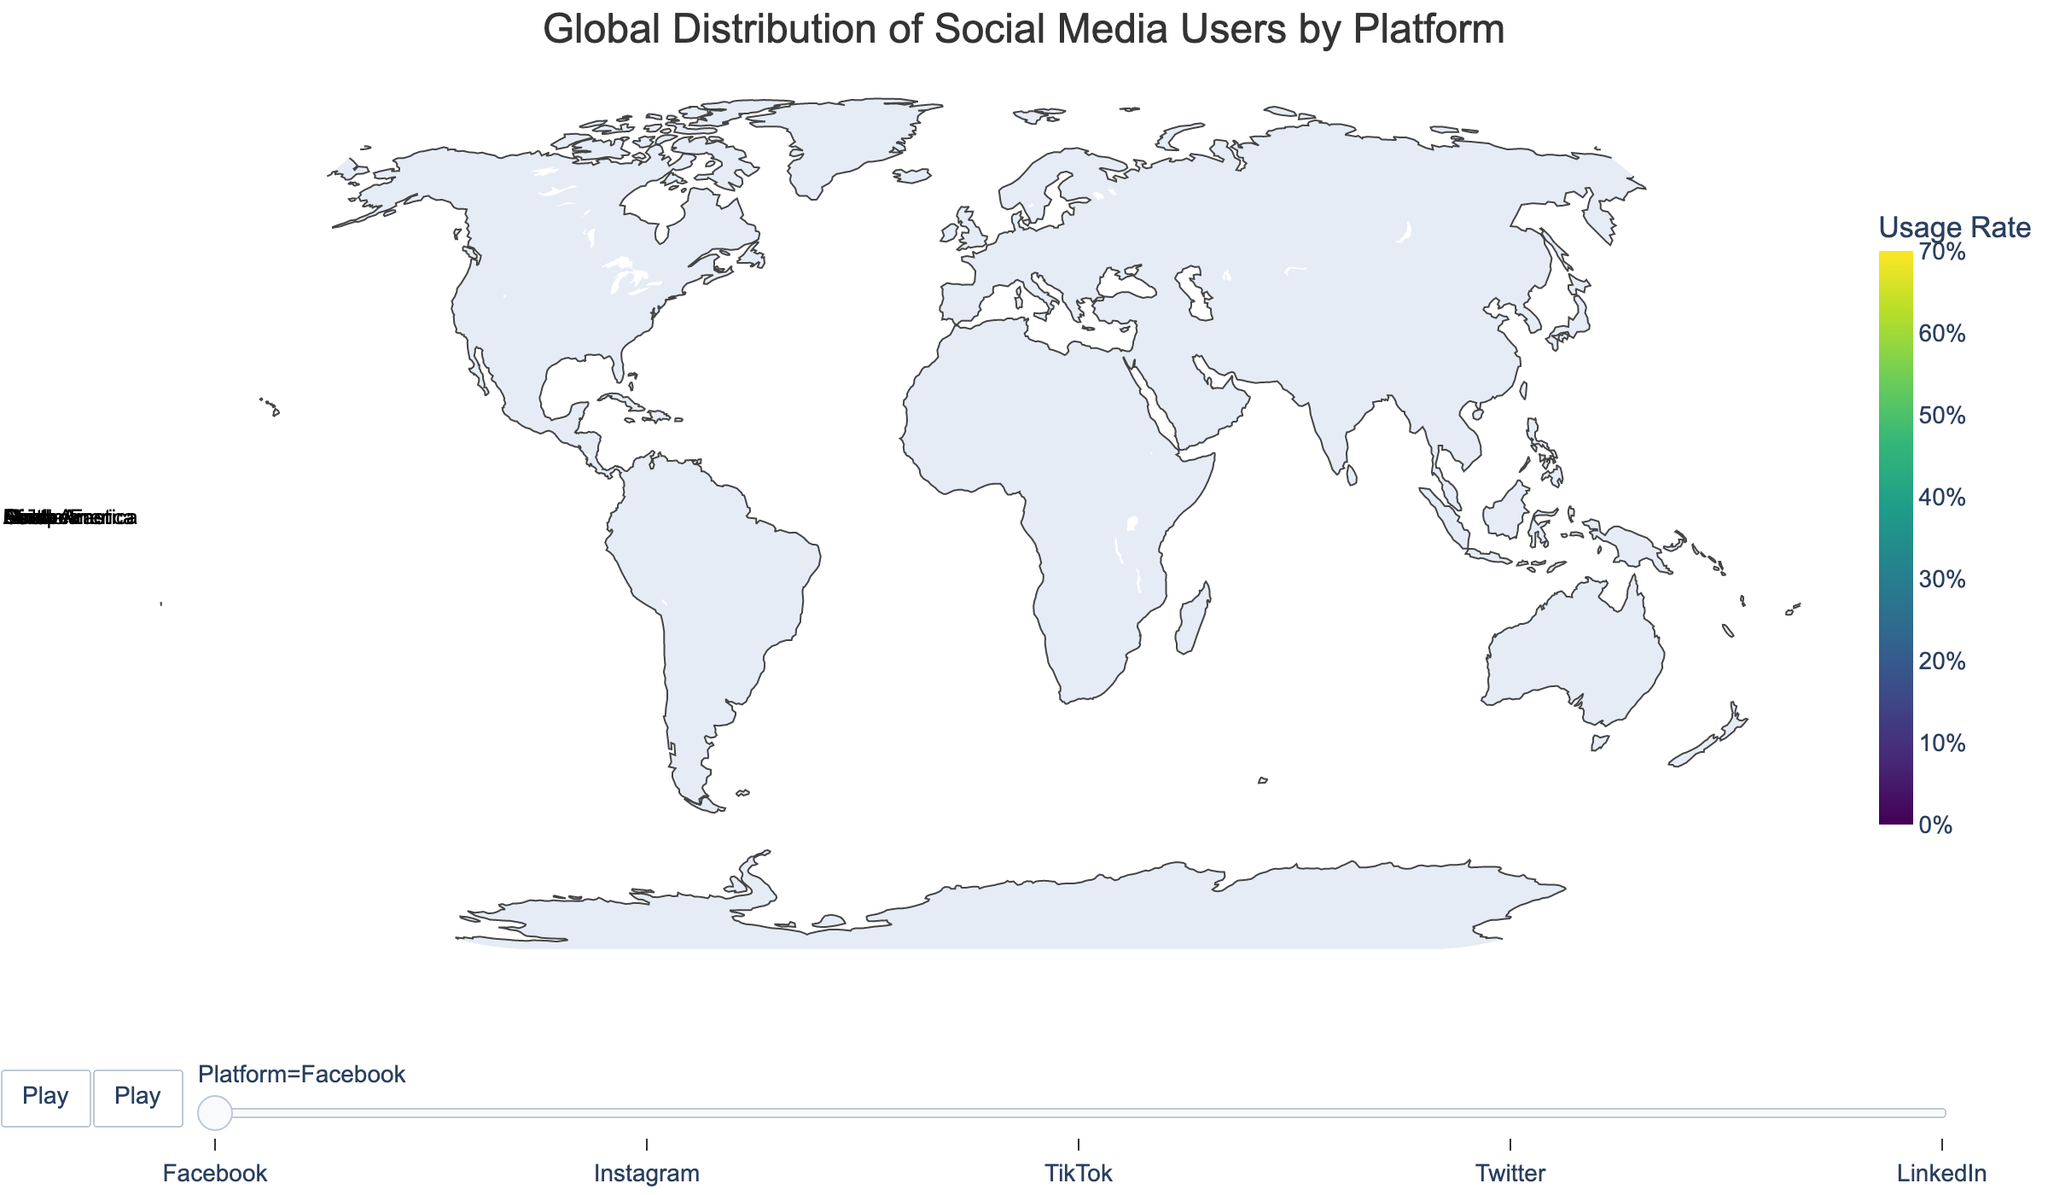What is the title of the plot? The title is usually displayed at the top center of the plot, summarizing what the figure is about.
Answer: Global Distribution of Social Media Users by Platform Which region has the highest usage rate for Facebook? Examine the different color intensities for the Facebook frame; the region with the most saturated color indicates the highest usage rate. South America shows the highest rate.
Answer: South America What is the range of the usage rate on the color bar? The color bar provides a visual representation of the range of data values. Notice that the color bar starts at 0 and ends at 0.7.
Answer: 0 to 0.7 (0% to 70%) In which region is LinkedIn the least popular? Checking the LinkedIn frame, identify the region with the least saturated color. Africa has the least usage rate for LinkedIn.
Answer: Africa Compare the popularity of Instagram between North America and Europe. Look at color intensities for Instagram in both North America and Europe. North America exhibits a slightly more saturated color than Europe.
Answer: North America > Europe What is the difference in TikTok usage rates between Asia and Africa? From the TikTok frame, refer to the usage rate percentages for Asia (45%) and Africa (22%). Calculate their difference: 45% - 22% = 23%.
Answer: 23% Which social media platform has the highest usage rate in Africa? By examining the highest color intensity in Africa across frames, Facebook emerges as the most widely used platform.
Answer: Facebook Order the regions descending by Twitter usage rate. Check Twitter usage rates across all regions and list them from highest to lowest: North America (25%), Europe (22%), Oceania (20%), South America (18%), Asia (15%), Middle East (14%), Africa (12%).
Answer: North America > Europe > Oceania > South America > Asia > Middle East > Africa In which region is the usage rate for Instagram closest to that of LinkedIn? Compare the percentages of Instagram and LinkedIn in each region. In Oceania, both have percentages close to each other (Instagram 35%, LinkedIn 25%).
Answer: Oceania What is the average usage rate for Facebook across all regions? Add up Facebook usage rates across regions and divide by the number of regions: (68% + 62% + 70% + 55% + 50% + 65% + 58%) / 7 ≈ 61%.
Answer: 61% 